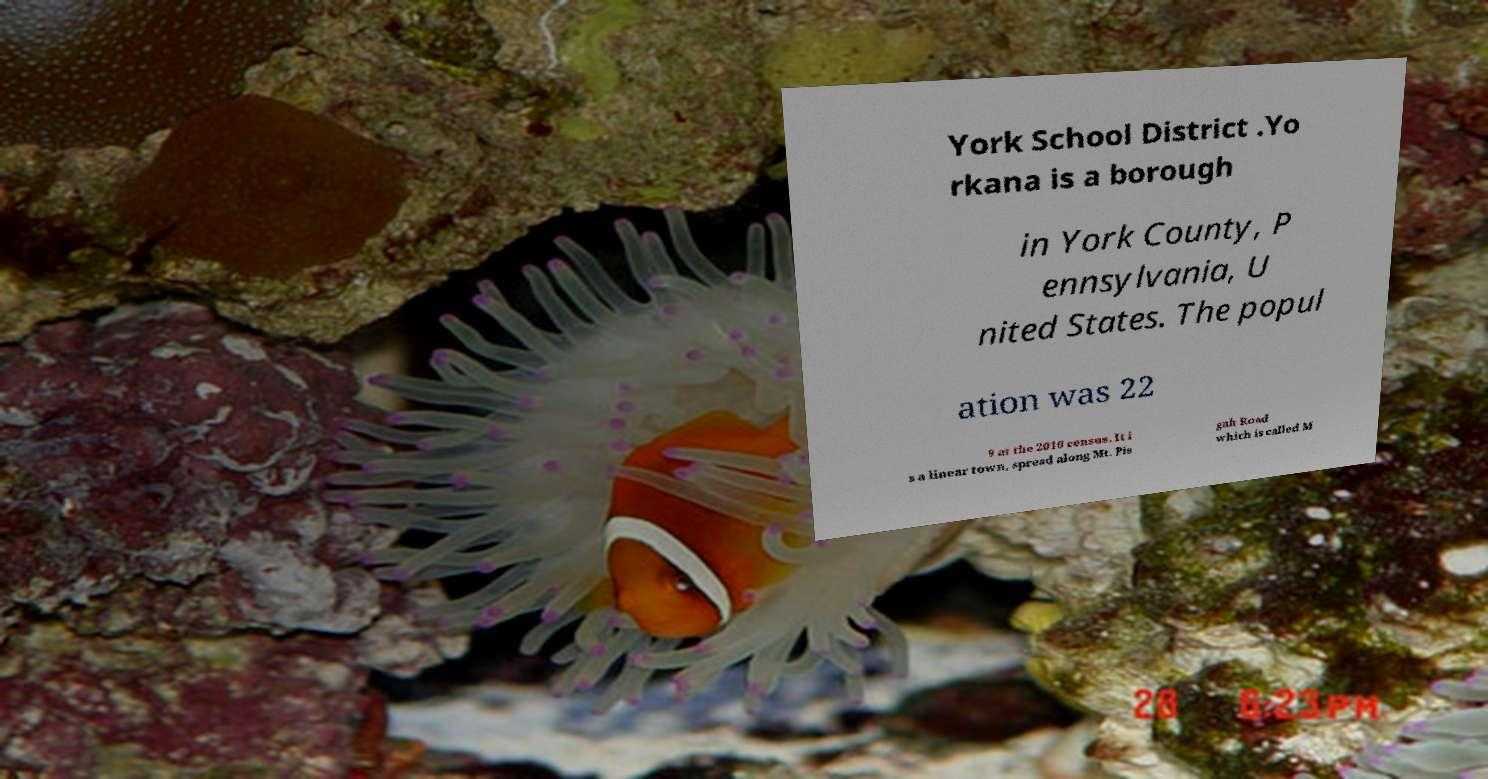Can you read and provide the text displayed in the image?This photo seems to have some interesting text. Can you extract and type it out for me? York School District .Yo rkana is a borough in York County, P ennsylvania, U nited States. The popul ation was 22 9 at the 2010 census. It i s a linear town, spread along Mt. Pis gah Road which is called M 